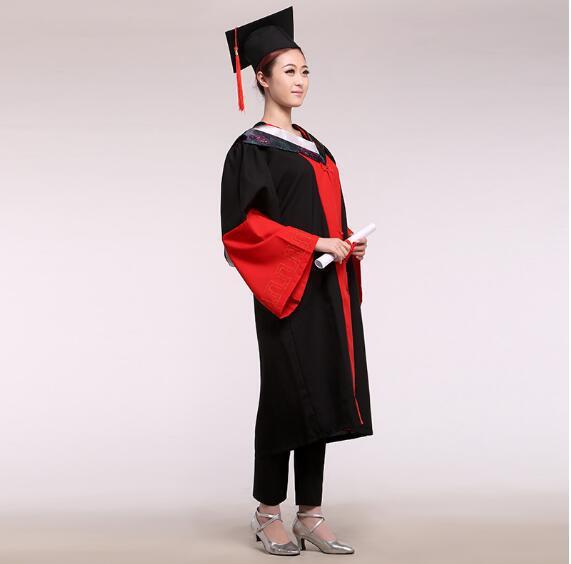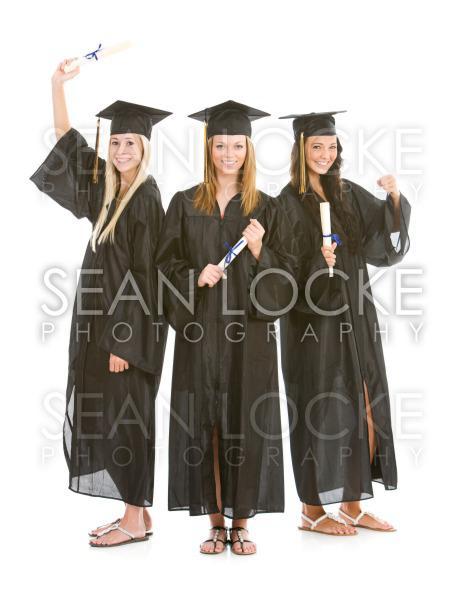The first image is the image on the left, the second image is the image on the right. Assess this claim about the two images: "In one image a graduation gown worn by a woman is black and red.". Correct or not? Answer yes or no. Yes. The first image is the image on the left, the second image is the image on the right. Assess this claim about the two images: "There is exactly one woman not holding a diploma in the image on the right". Correct or not? Answer yes or no. No. 